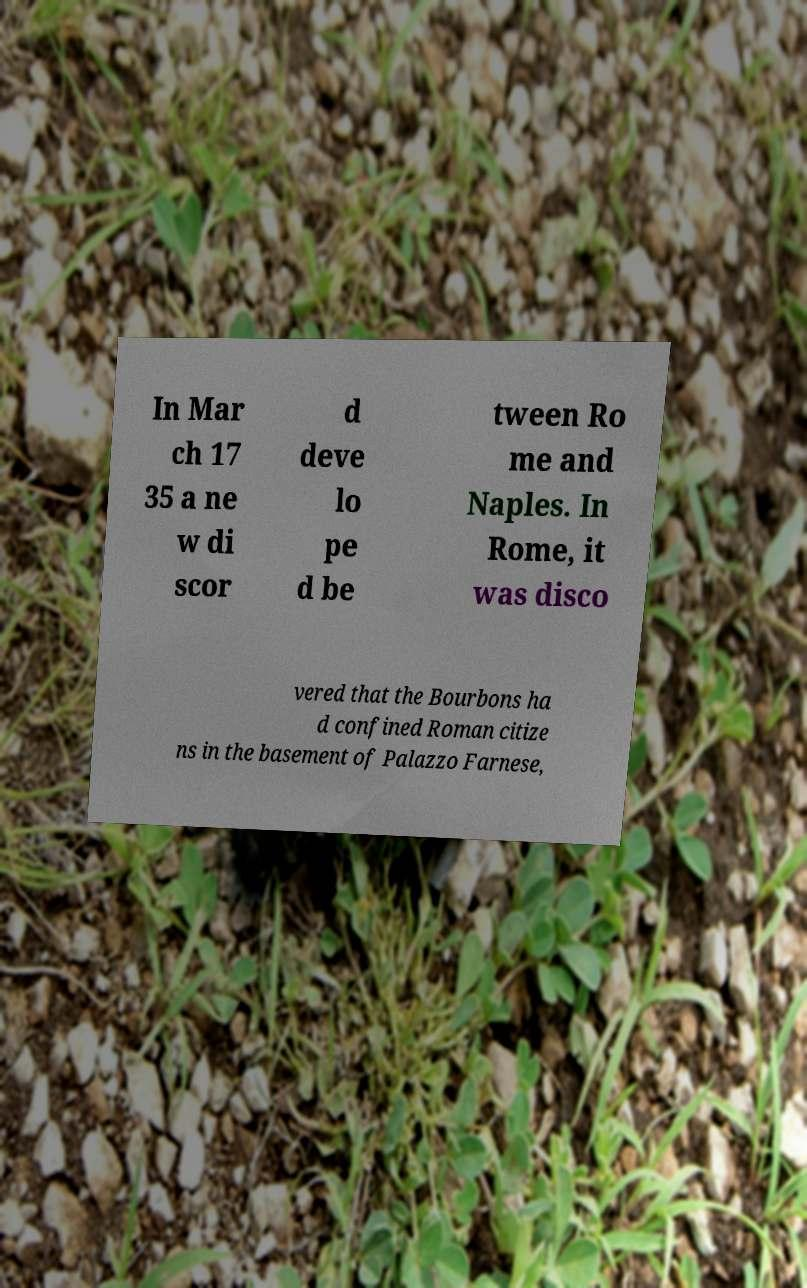There's text embedded in this image that I need extracted. Can you transcribe it verbatim? In Mar ch 17 35 a ne w di scor d deve lo pe d be tween Ro me and Naples. In Rome, it was disco vered that the Bourbons ha d confined Roman citize ns in the basement of Palazzo Farnese, 